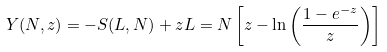<formula> <loc_0><loc_0><loc_500><loc_500>Y ( N , z ) = - S ( L , N ) + z L = N \left [ z - \ln \left ( \frac { 1 - e ^ { - z } } { z } \right ) \right ]</formula> 